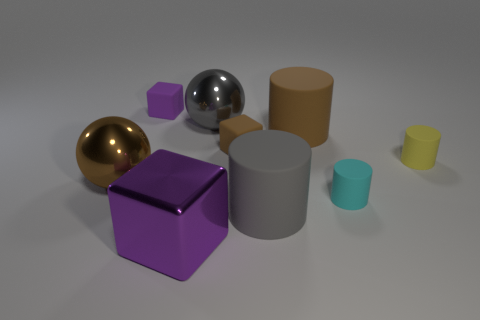Add 1 tiny cylinders. How many objects exist? 10 Subtract all blue cylinders. Subtract all cyan cubes. How many cylinders are left? 4 Subtract all spheres. How many objects are left? 7 Subtract all large metal balls. Subtract all small brown objects. How many objects are left? 6 Add 2 large brown matte objects. How many large brown matte objects are left? 3 Add 1 small green matte spheres. How many small green matte spheres exist? 1 Subtract 1 cyan cylinders. How many objects are left? 8 